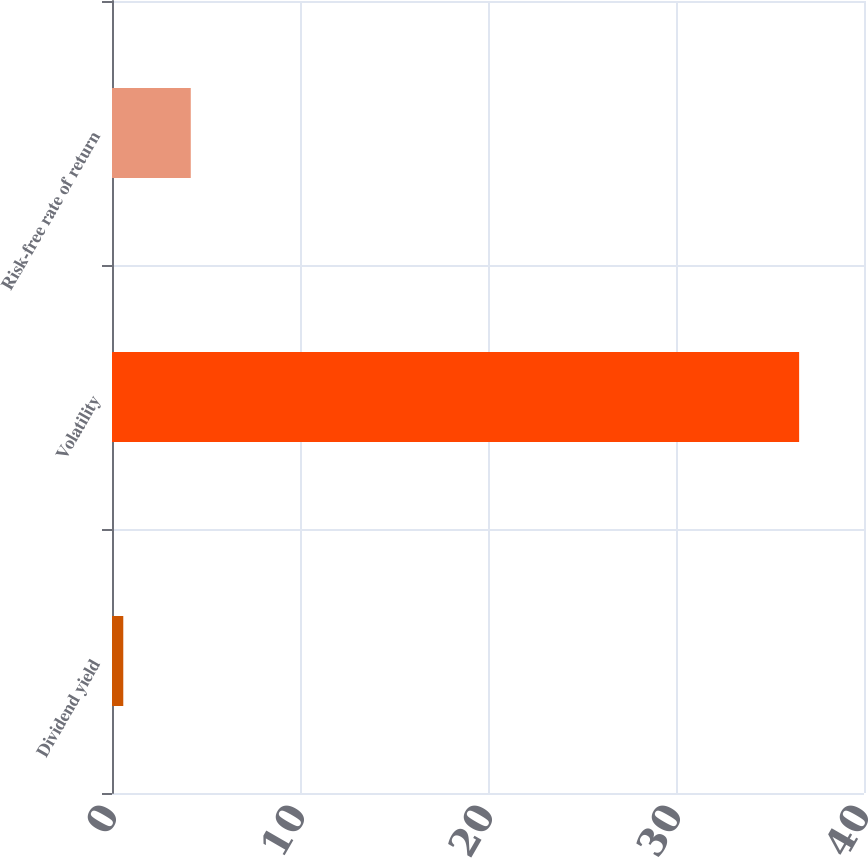Convert chart to OTSL. <chart><loc_0><loc_0><loc_500><loc_500><bar_chart><fcel>Dividend yield<fcel>Volatility<fcel>Risk-free rate of return<nl><fcel>0.6<fcel>36.55<fcel>4.19<nl></chart> 